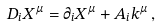<formula> <loc_0><loc_0><loc_500><loc_500>D _ { i } X ^ { \mu } = \partial _ { i } X ^ { \mu } + A _ { i } k ^ { \mu } \, ,</formula> 